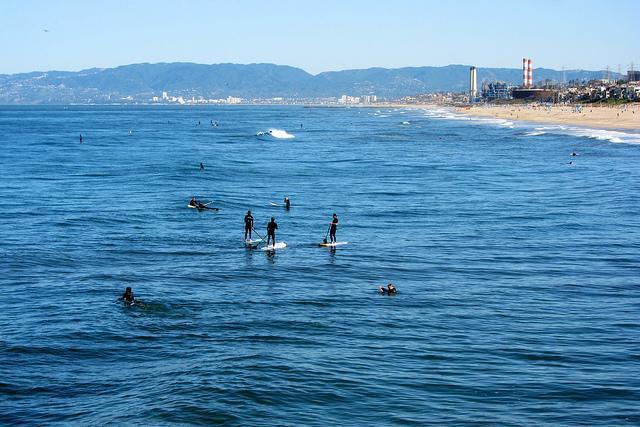How many elephants are there?
Give a very brief answer. 0. 